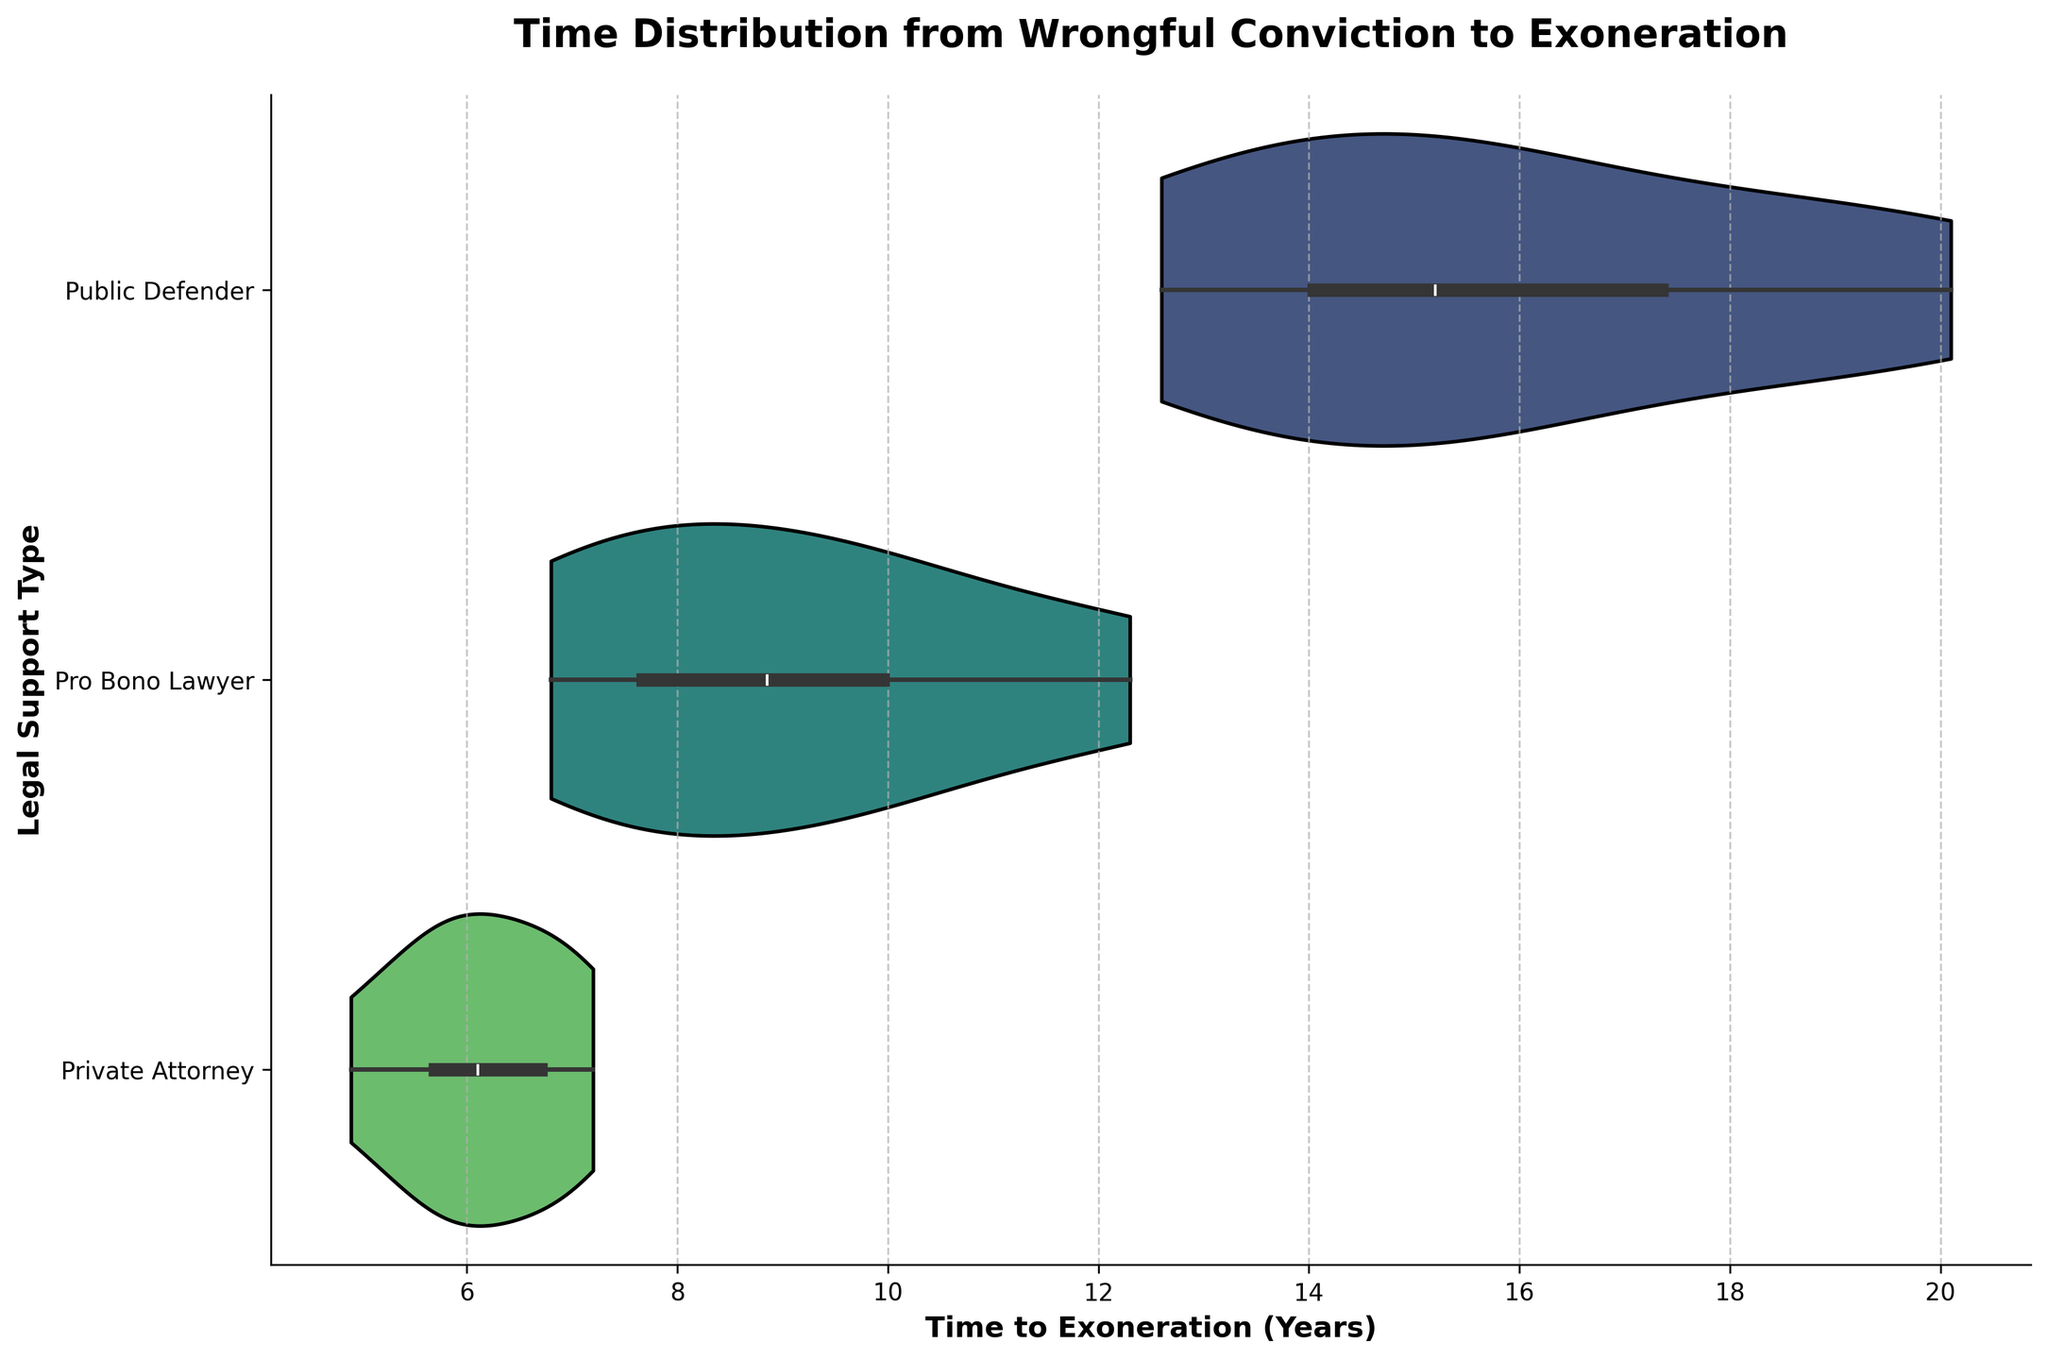What is the title of the figure? The title is located at the top of the figure and typically describes the content and purpose of the visualization. In this case, it states the subject of the data being displayed.
Answer: Time Distribution from Wrongful Conviction to Exoneration Which type of legal support shows the widest distribution of time to exoneration? The width of the violin plot indicates the distribution spread. The widest distribution shows the most variability in the data.
Answer: Public Defender Which type of legal support has the shortest time to exoneration on average? To determine this, look at the central tendency (usually the thicker section in the middle) of each violin plot. The one that appears to be more towards the left on the x-axis suggests a shorter average time.
Answer: Private Attorney What is the approximate range of years for cases involving Pro Bono Lawyers? The range is indicated by the length of the violin plot along the x-axis. For Pro Bono Lawyers, look at the start and end points of the plot.
Answer: Approximately 6.8 to 12.3 years Which legal support type has the most cases evaluated in the visualization? Examine the density and width of the violins. The plot with the most filled-in area suggests a higher number of data points.
Answer: Public Defender How does the median time to exoneration for Public Defenders compare to that for Private Attorneys? The median is usually indicated by the thickest part of the violin or by an inner box plot. Compare the central positions of the plots for both legal supports.
Answer: The median time for Public Defenders is higher than for Private Attorneys What is the median time to exoneration for Pro Bono Lawyers? The median is typically represented by the thickest section of the violin or a line inside the violin plot. For Pro Bono Lawyers, identify this central value.
Answer: Approximately 8.2 years Which group shows the smallest spread in time to exoneration? The group with the smallest spread will have the narrowest violin plot in terms of x-axis coverage.
Answer: Private Attorney Among the three types of legal support, which group seems to have a few extreme values? Extreme values create longer tails on the violin plot. Look for any violin plots with noticeably long tails extending further out from the main body of the distribution.
Answer: Public Defender Is there a noticeable difference in the maximum time to exoneration between the different legal support types? Compare the farthest right points on each of the violin plots to see if they reach significantly different maximum values.
Answer: Yes, Public Defender has the highest maximum time, while Private Attorney has the lowest 